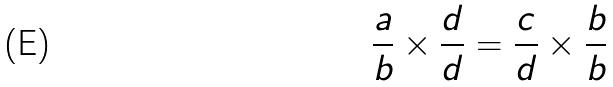<formula> <loc_0><loc_0><loc_500><loc_500>\frac { a } { b } \times \frac { d } { d } = \frac { c } { d } \times \frac { b } { b }</formula> 